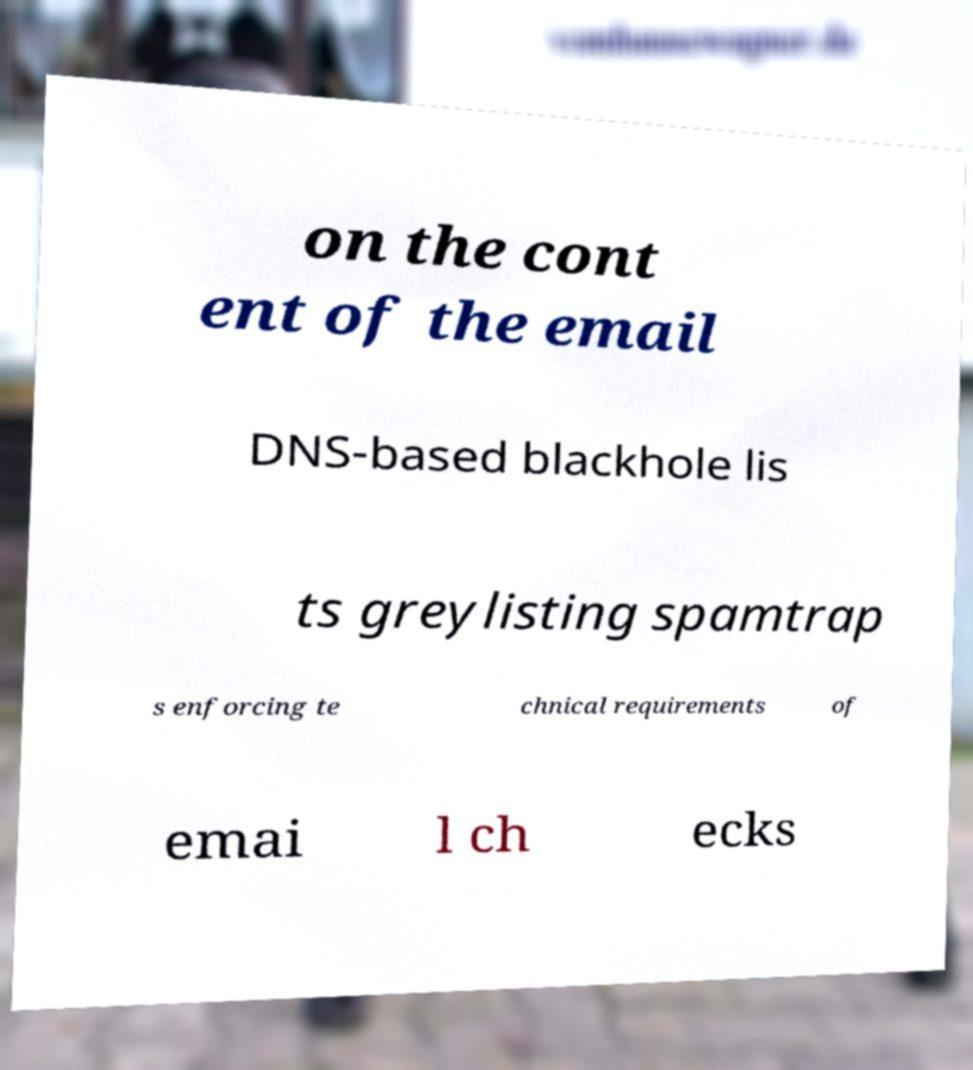I need the written content from this picture converted into text. Can you do that? on the cont ent of the email DNS-based blackhole lis ts greylisting spamtrap s enforcing te chnical requirements of emai l ch ecks 